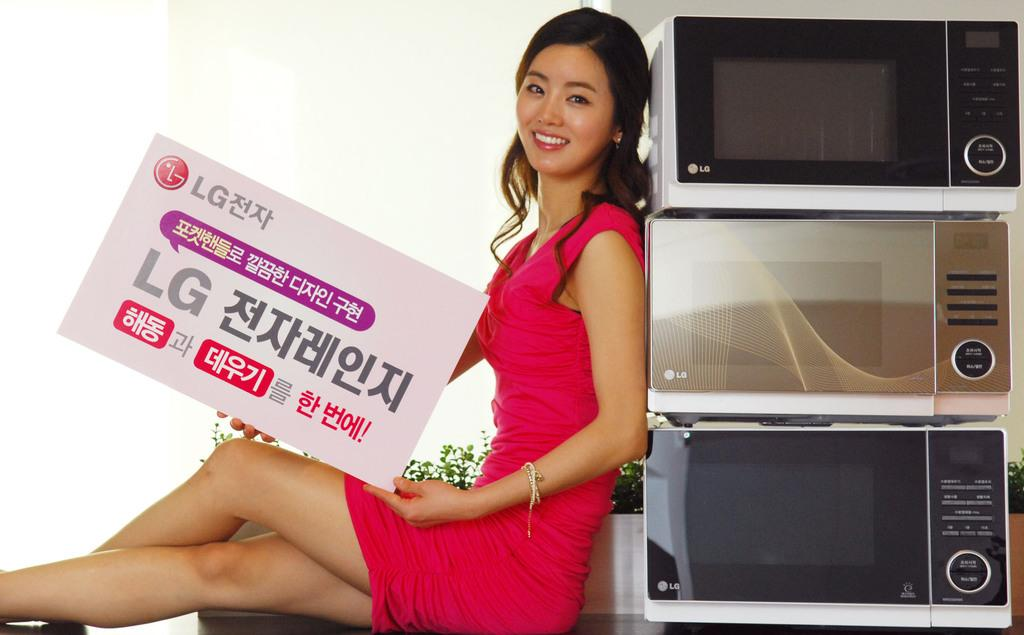<image>
Summarize the visual content of the image. A woman in a red dress is holding an LG brand box, and leaning against three other LG devices 